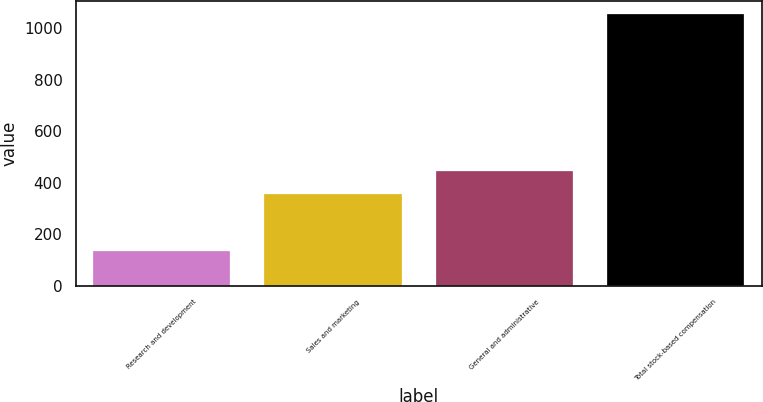Convert chart to OTSL. <chart><loc_0><loc_0><loc_500><loc_500><bar_chart><fcel>Research and development<fcel>Sales and marketing<fcel>General and administrative<fcel>Total stock-based compensation<nl><fcel>135<fcel>354<fcel>445.9<fcel>1054<nl></chart> 